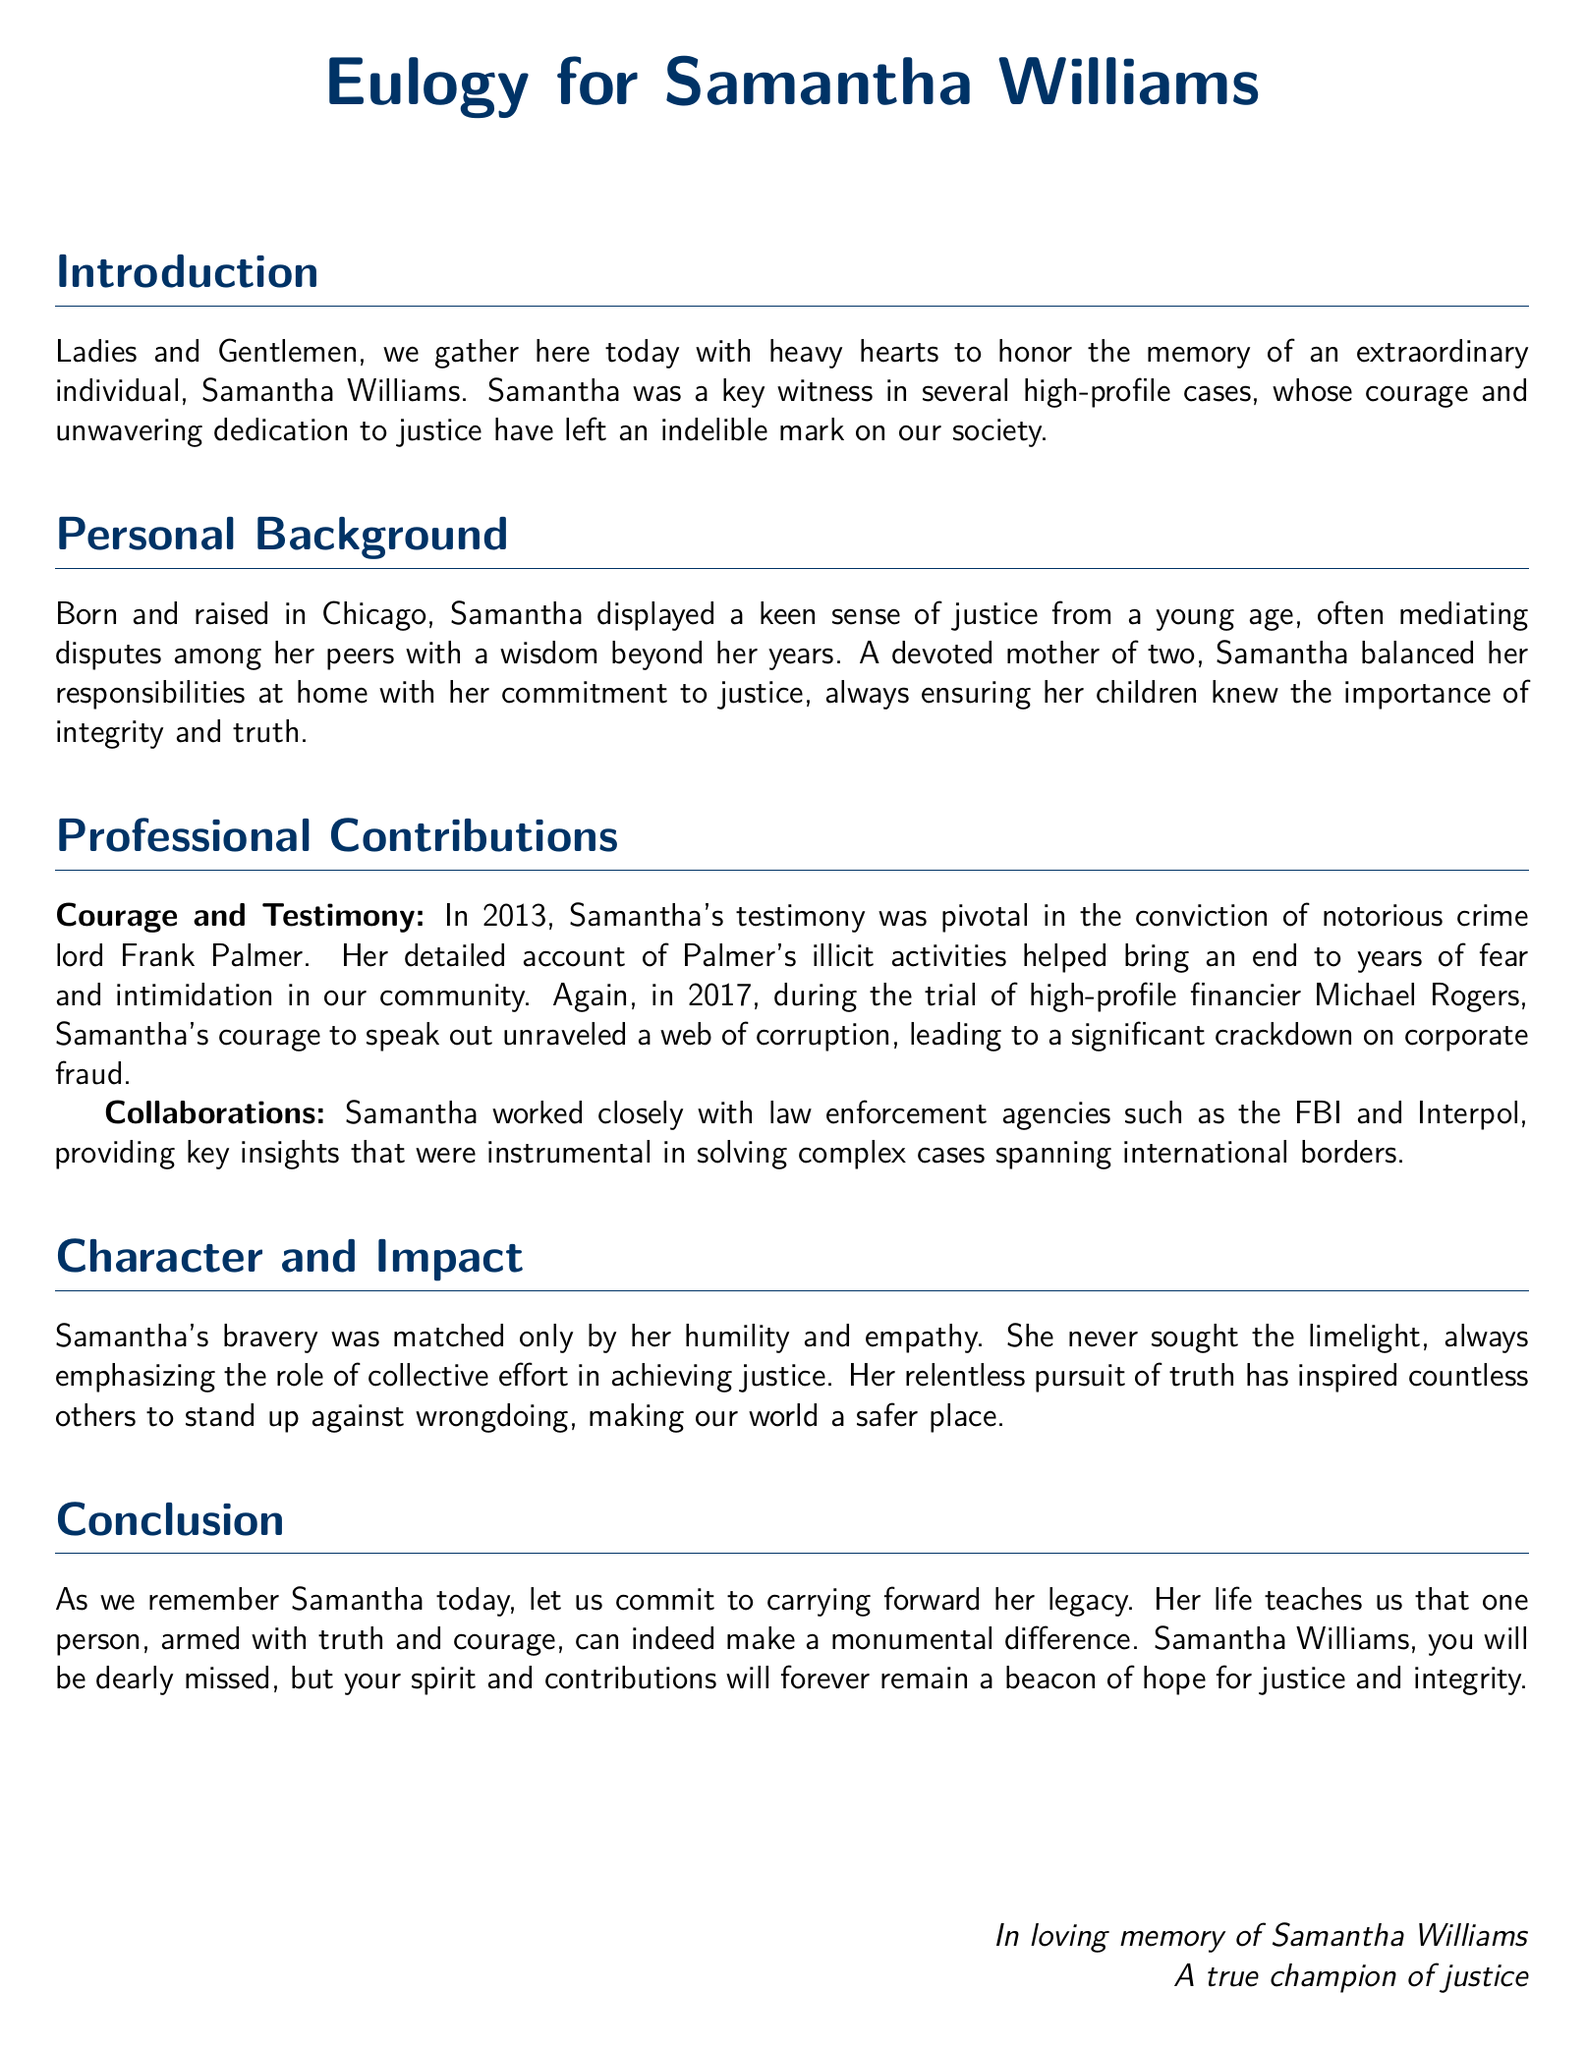What is the name of the key witness? The document mentions the key witness as Samantha Williams.
Answer: Samantha Williams In what year did Samantha testify against Frank Palmer? The eulogy states that Samantha's testimony was pivotal in 2013.
Answer: 2013 What was the profession of Michael Rogers? The document describes Michael Rogers as a high-profile financier.
Answer: Financier What city was Samantha Williams born and raised in? The eulogy mentions that she was born and raised in Chicago.
Answer: Chicago How many children did Samantha have? The document indicates that Samantha was a devoted mother of two.
Answer: Two What did Samantha emphasize in her work regarding justice? The eulogy states she always emphasized the role of collective effort.
Answer: Collective effort What type of agencies did Samantha collaborate with? The document mentions that she worked closely with law enforcement agencies.
Answer: Law enforcement agencies What year did Samantha witness a significant crackdown on corporate fraud? The document states this occurred during the trial in 2017.
Answer: 2017 What is the sentiment expressed towards Samantha's contributions? The eulogy reflects admiration and appreciation for her impact on justice.
Answer: Admiration 